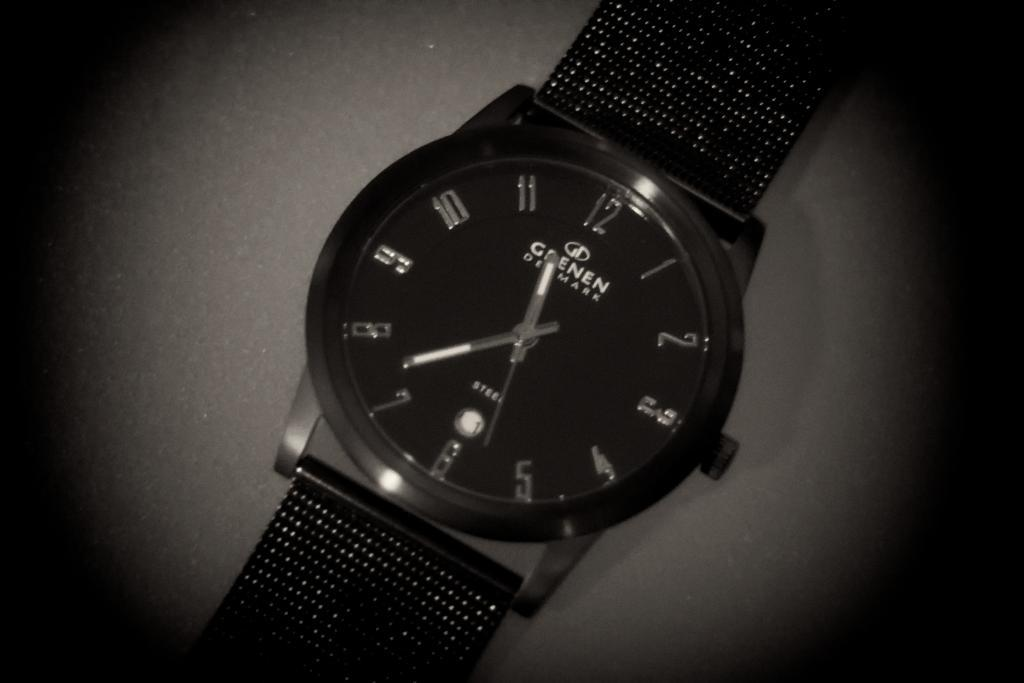<image>
Relay a brief, clear account of the picture shown. A black Grenen watch from Denmark lays flat. 